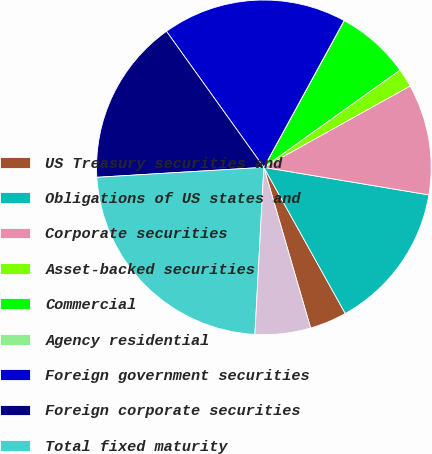Convert chart. <chart><loc_0><loc_0><loc_500><loc_500><pie_chart><fcel>US Treasury securities and<fcel>Obligations of US states and<fcel>Corporate securities<fcel>Asset-backed securities<fcel>Commercial<fcel>Agency residential<fcel>Foreign government securities<fcel>Foreign corporate securities<fcel>Total fixed maturity<fcel>Due in one year or less<nl><fcel>3.58%<fcel>14.28%<fcel>10.71%<fcel>1.8%<fcel>7.15%<fcel>0.01%<fcel>17.85%<fcel>16.06%<fcel>23.2%<fcel>5.36%<nl></chart> 